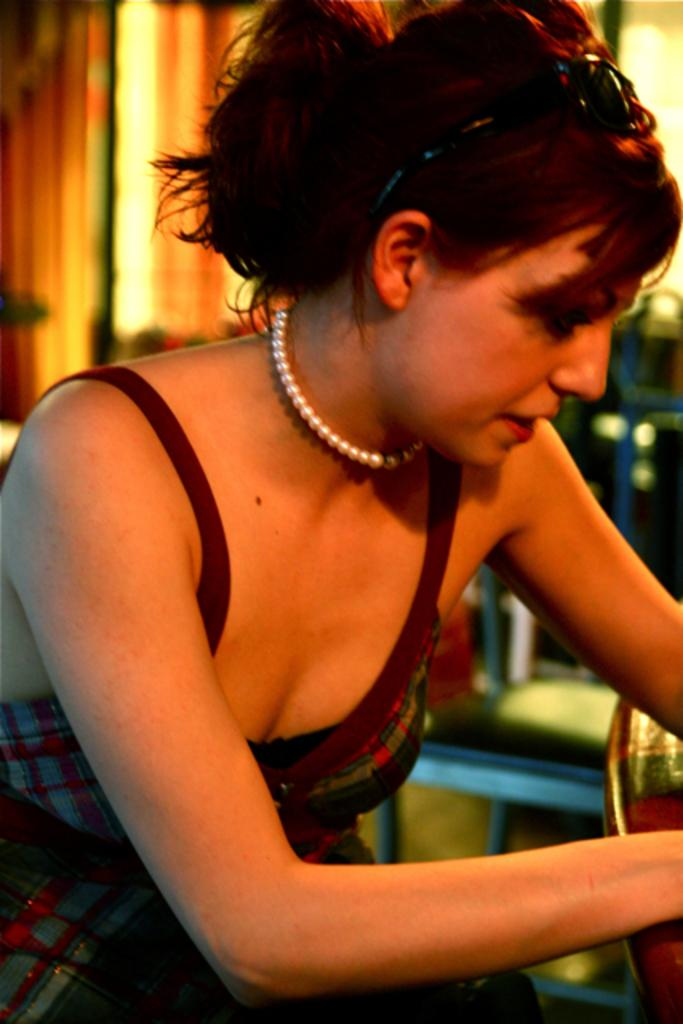Who is the main subject in the image? There is a girl in the image. Can you describe the background of the image? The background of the image is blurred. What type of waste can be seen in the image? There is no waste present in the image. What season is depicted in the image? The provided facts do not mention any season, so it cannot be determined from the image. 